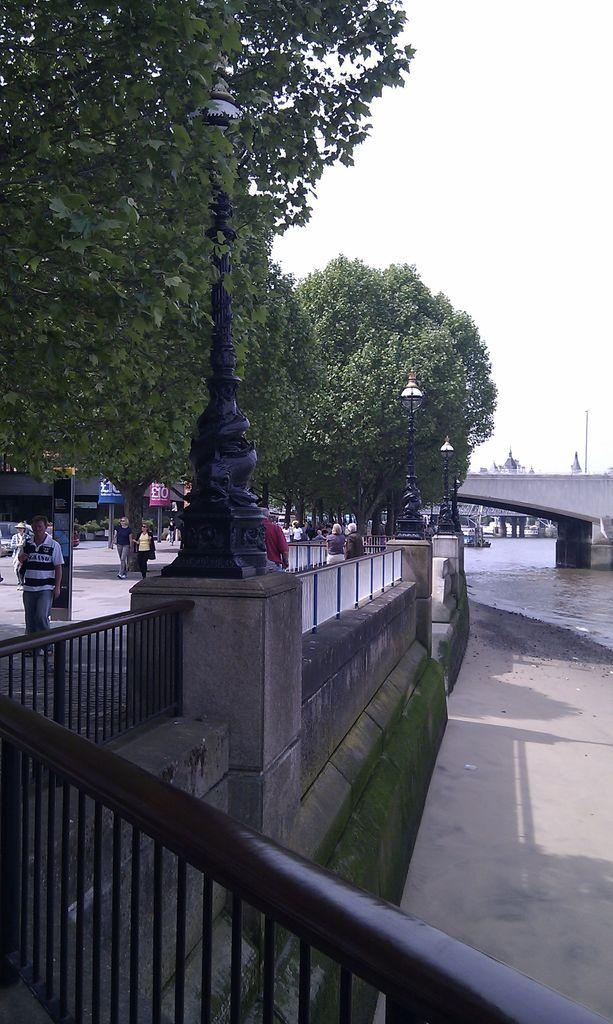What type of vegetation can be seen in the middle of the image? There are trees in the middle of the image. What is visible at the top of the image? The sky is visible at the top of the image. What structure is located on the right side of the image? There is a bridge on the right side of the image. What can be seen on the left side of the image? There are people on the left side of the image. What type of punishment is being administered to the rat in the image? There is no rat present in the image, and therefore no punishment is being administered. What is the temperature like in the image? The temperature or heat level cannot be determined from the image, as it only shows trees, sky, a bridge, and people. 